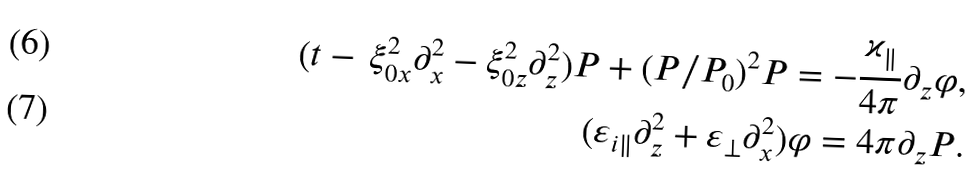<formula> <loc_0><loc_0><loc_500><loc_500>( t - \, \xi _ { 0 x } ^ { 2 } \partial _ { x } ^ { 2 } - \xi _ { 0 z } ^ { 2 } \partial _ { z } ^ { 2 } ) P + ( P / P _ { 0 } ) ^ { 2 } P = - \frac { \varkappa _ { \| } } { 4 \pi } \partial _ { z } \varphi , \\ ( \varepsilon _ { i \| } \partial _ { z } ^ { 2 } + \varepsilon _ { \perp } \partial _ { x } ^ { 2 } ) \varphi = 4 \pi \partial _ { z } P .</formula> 